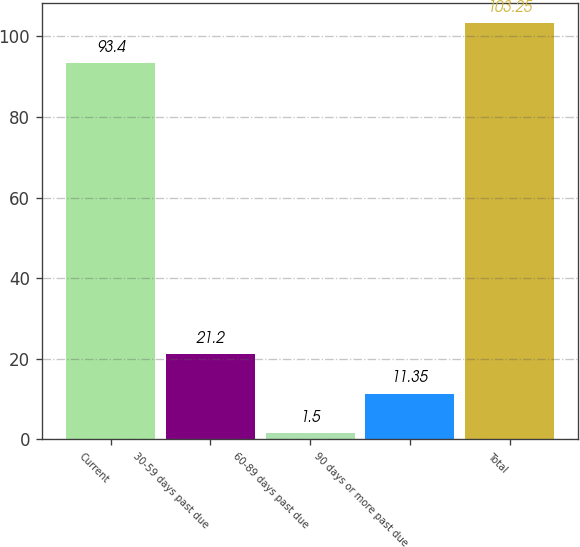Convert chart. <chart><loc_0><loc_0><loc_500><loc_500><bar_chart><fcel>Current<fcel>30-59 days past due<fcel>60-89 days past due<fcel>90 days or more past due<fcel>Total<nl><fcel>93.4<fcel>21.2<fcel>1.5<fcel>11.35<fcel>103.25<nl></chart> 